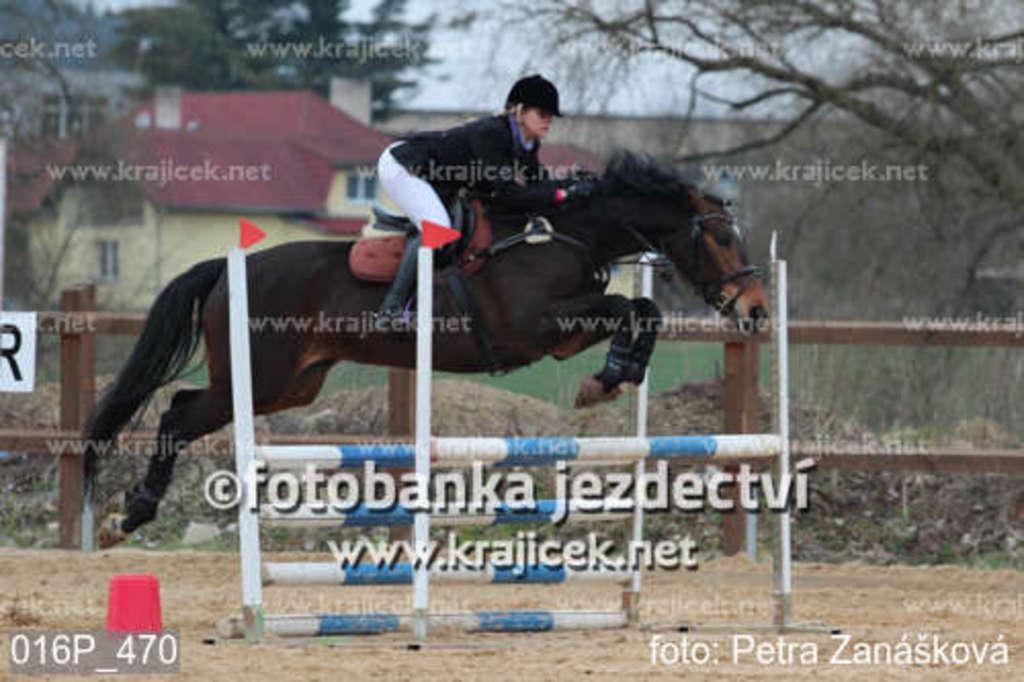Can you describe this image briefly? In the foreground of the picture there are sand, bucket, iron frame and a woman riding a horse. In the center of the picture there are plants, soil, fencing and grass. In the background there are trees, buildings and sky. On this pictures there is text. 